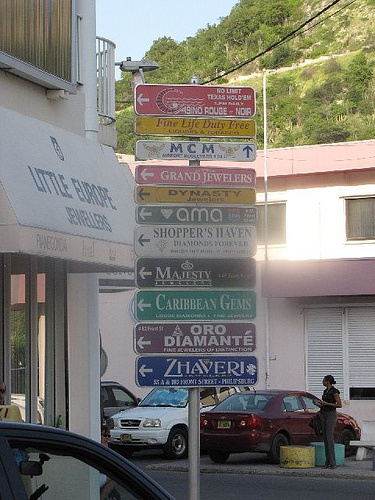Describe the objects in this image and their specific colors. I can see car in gray, black, and darkblue tones, car in gray, black, maroon, and purple tones, truck in gray, black, and darkgray tones, people in gray, black, maroon, and darkgray tones, and truck in gray, black, and purple tones in this image. 